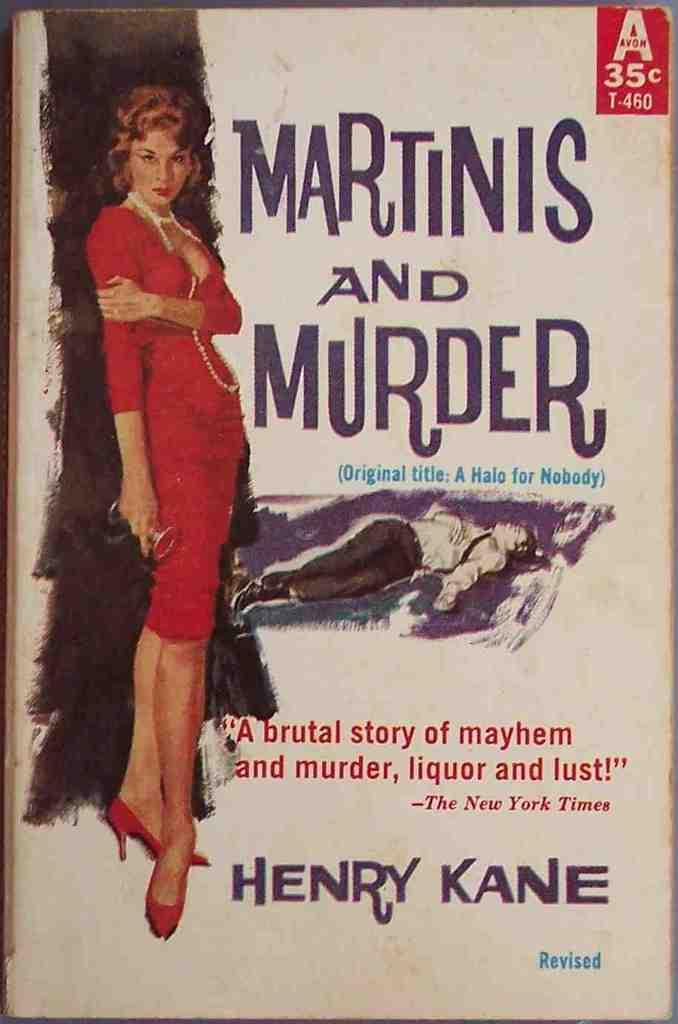<image>
Render a clear and concise summary of the photo. Old book entitled Martinis and Murder by Henry Kane. 